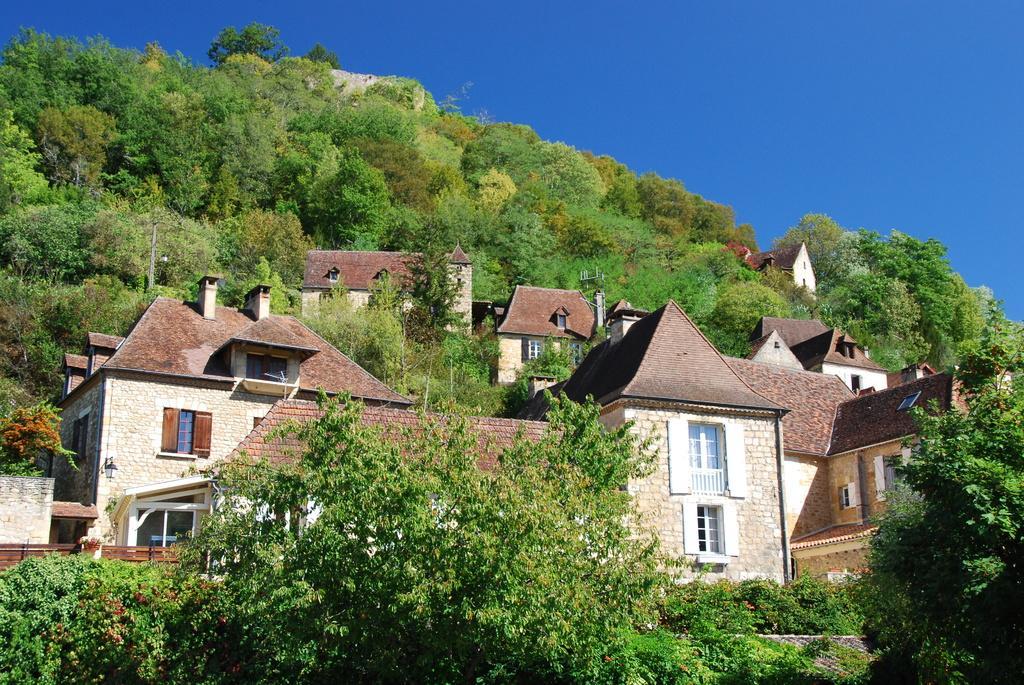Could you give a brief overview of what you see in this image? In this picture we can see many houses surrounded by trees. The sky is blue. 